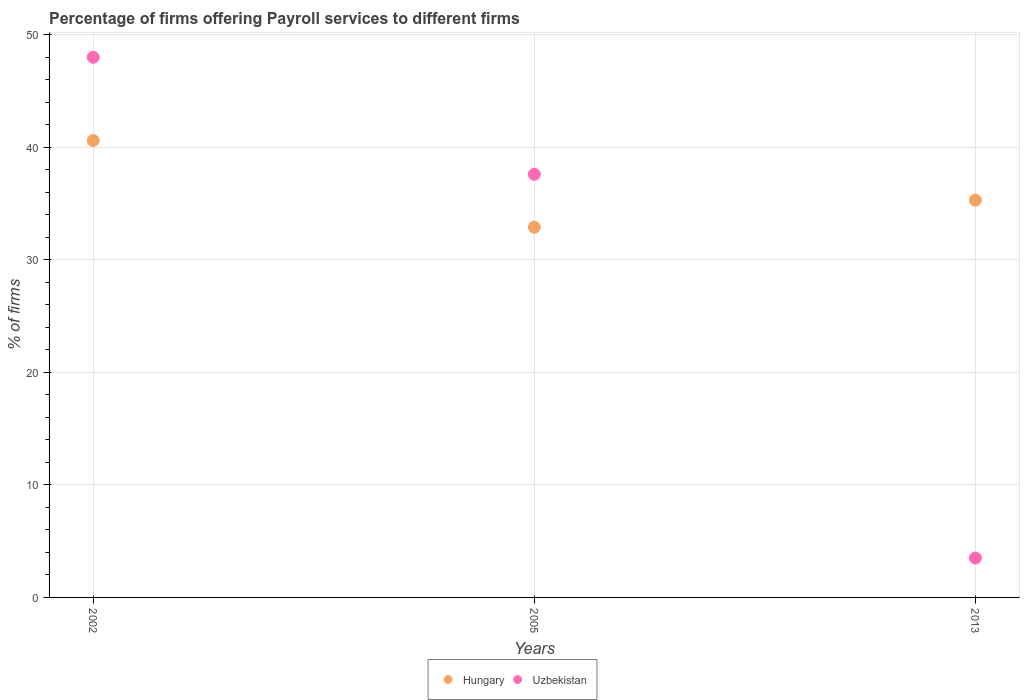How many different coloured dotlines are there?
Offer a very short reply. 2. What is the percentage of firms offering payroll services in Uzbekistan in 2005?
Offer a terse response. 37.6. Across all years, what is the minimum percentage of firms offering payroll services in Hungary?
Your response must be concise. 32.9. What is the total percentage of firms offering payroll services in Uzbekistan in the graph?
Provide a succinct answer. 89.1. What is the difference between the percentage of firms offering payroll services in Hungary in 2005 and that in 2013?
Make the answer very short. -2.4. What is the difference between the percentage of firms offering payroll services in Uzbekistan in 2002 and the percentage of firms offering payroll services in Hungary in 2013?
Your answer should be compact. 12.7. What is the average percentage of firms offering payroll services in Uzbekistan per year?
Your response must be concise. 29.7. In the year 2002, what is the difference between the percentage of firms offering payroll services in Uzbekistan and percentage of firms offering payroll services in Hungary?
Keep it short and to the point. 7.4. In how many years, is the percentage of firms offering payroll services in Hungary greater than 4 %?
Provide a succinct answer. 3. What is the ratio of the percentage of firms offering payroll services in Uzbekistan in 2002 to that in 2013?
Your response must be concise. 13.71. Is the percentage of firms offering payroll services in Uzbekistan in 2002 less than that in 2005?
Your response must be concise. No. Is the difference between the percentage of firms offering payroll services in Uzbekistan in 2005 and 2013 greater than the difference between the percentage of firms offering payroll services in Hungary in 2005 and 2013?
Ensure brevity in your answer.  Yes. What is the difference between the highest and the second highest percentage of firms offering payroll services in Uzbekistan?
Offer a very short reply. 10.4. What is the difference between the highest and the lowest percentage of firms offering payroll services in Hungary?
Provide a short and direct response. 7.7. Is the sum of the percentage of firms offering payroll services in Uzbekistan in 2005 and 2013 greater than the maximum percentage of firms offering payroll services in Hungary across all years?
Provide a short and direct response. Yes. Does the percentage of firms offering payroll services in Uzbekistan monotonically increase over the years?
Ensure brevity in your answer.  No. How many dotlines are there?
Offer a very short reply. 2. What is the difference between two consecutive major ticks on the Y-axis?
Your answer should be compact. 10. Are the values on the major ticks of Y-axis written in scientific E-notation?
Provide a short and direct response. No. Does the graph contain any zero values?
Keep it short and to the point. No. Where does the legend appear in the graph?
Offer a terse response. Bottom center. How are the legend labels stacked?
Offer a very short reply. Horizontal. What is the title of the graph?
Your answer should be compact. Percentage of firms offering Payroll services to different firms. Does "Tajikistan" appear as one of the legend labels in the graph?
Provide a succinct answer. No. What is the label or title of the X-axis?
Provide a succinct answer. Years. What is the label or title of the Y-axis?
Make the answer very short. % of firms. What is the % of firms in Hungary in 2002?
Offer a terse response. 40.6. What is the % of firms of Uzbekistan in 2002?
Make the answer very short. 48. What is the % of firms in Hungary in 2005?
Offer a very short reply. 32.9. What is the % of firms of Uzbekistan in 2005?
Offer a very short reply. 37.6. What is the % of firms of Hungary in 2013?
Your answer should be very brief. 35.3. What is the % of firms of Uzbekistan in 2013?
Ensure brevity in your answer.  3.5. Across all years, what is the maximum % of firms in Hungary?
Give a very brief answer. 40.6. Across all years, what is the minimum % of firms of Hungary?
Give a very brief answer. 32.9. What is the total % of firms in Hungary in the graph?
Your answer should be compact. 108.8. What is the total % of firms of Uzbekistan in the graph?
Your response must be concise. 89.1. What is the difference between the % of firms of Hungary in 2002 and that in 2005?
Make the answer very short. 7.7. What is the difference between the % of firms of Hungary in 2002 and that in 2013?
Provide a short and direct response. 5.3. What is the difference between the % of firms of Uzbekistan in 2002 and that in 2013?
Provide a short and direct response. 44.5. What is the difference between the % of firms in Hungary in 2005 and that in 2013?
Offer a terse response. -2.4. What is the difference between the % of firms in Uzbekistan in 2005 and that in 2013?
Provide a succinct answer. 34.1. What is the difference between the % of firms of Hungary in 2002 and the % of firms of Uzbekistan in 2013?
Provide a succinct answer. 37.1. What is the difference between the % of firms of Hungary in 2005 and the % of firms of Uzbekistan in 2013?
Make the answer very short. 29.4. What is the average % of firms in Hungary per year?
Your answer should be very brief. 36.27. What is the average % of firms of Uzbekistan per year?
Your answer should be very brief. 29.7. In the year 2002, what is the difference between the % of firms in Hungary and % of firms in Uzbekistan?
Keep it short and to the point. -7.4. In the year 2013, what is the difference between the % of firms in Hungary and % of firms in Uzbekistan?
Offer a terse response. 31.8. What is the ratio of the % of firms in Hungary in 2002 to that in 2005?
Offer a terse response. 1.23. What is the ratio of the % of firms of Uzbekistan in 2002 to that in 2005?
Offer a terse response. 1.28. What is the ratio of the % of firms in Hungary in 2002 to that in 2013?
Your answer should be very brief. 1.15. What is the ratio of the % of firms of Uzbekistan in 2002 to that in 2013?
Ensure brevity in your answer.  13.71. What is the ratio of the % of firms of Hungary in 2005 to that in 2013?
Provide a succinct answer. 0.93. What is the ratio of the % of firms of Uzbekistan in 2005 to that in 2013?
Offer a terse response. 10.74. What is the difference between the highest and the lowest % of firms of Hungary?
Offer a terse response. 7.7. What is the difference between the highest and the lowest % of firms in Uzbekistan?
Offer a terse response. 44.5. 